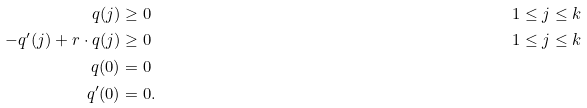<formula> <loc_0><loc_0><loc_500><loc_500>q ( j ) & \geq 0 & & 1 \leq j \leq k \\ - q ^ { \prime } ( j ) + r \cdot q ( j ) & \geq 0 & & 1 \leq j \leq k \\ q ( 0 ) & = 0 \\ q ^ { \prime } ( 0 ) & = 0 .</formula> 